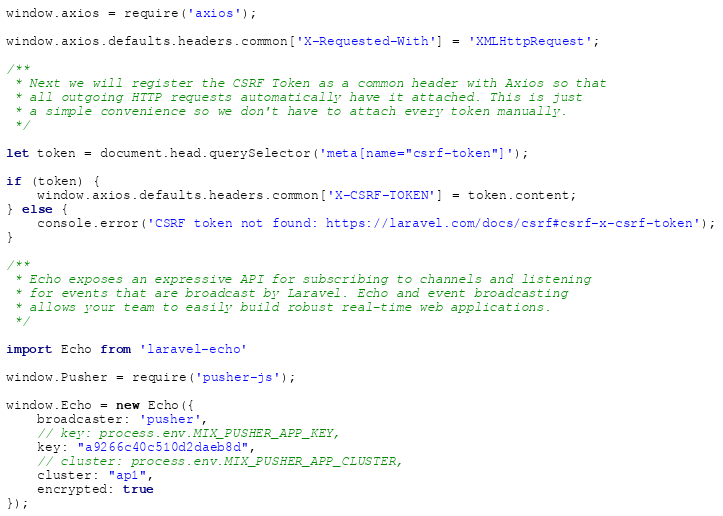Convert code to text. <code><loc_0><loc_0><loc_500><loc_500><_JavaScript_>
window.axios = require('axios');

window.axios.defaults.headers.common['X-Requested-With'] = 'XMLHttpRequest';

/**
 * Next we will register the CSRF Token as a common header with Axios so that
 * all outgoing HTTP requests automatically have it attached. This is just
 * a simple convenience so we don't have to attach every token manually.
 */

let token = document.head.querySelector('meta[name="csrf-token"]');

if (token) {
    window.axios.defaults.headers.common['X-CSRF-TOKEN'] = token.content;
} else {
    console.error('CSRF token not found: https://laravel.com/docs/csrf#csrf-x-csrf-token');
}

/**
 * Echo exposes an expressive API for subscribing to channels and listening
 * for events that are broadcast by Laravel. Echo and event broadcasting
 * allows your team to easily build robust real-time web applications.
 */

import Echo from 'laravel-echo'

window.Pusher = require('pusher-js');

window.Echo = new Echo({
    broadcaster: 'pusher',
    // key: process.env.MIX_PUSHER_APP_KEY,
    key: "a9266c40c510d2daeb8d",
    // cluster: process.env.MIX_PUSHER_APP_CLUSTER,
    cluster: "ap1",
    encrypted: true
});
</code> 